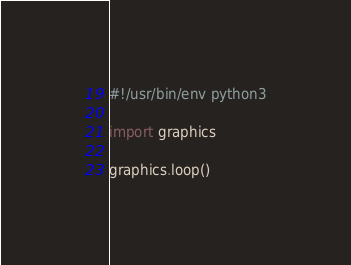Convert code to text. <code><loc_0><loc_0><loc_500><loc_500><_Python_>#!/usr/bin/env python3

import graphics

graphics.loop()


</code> 